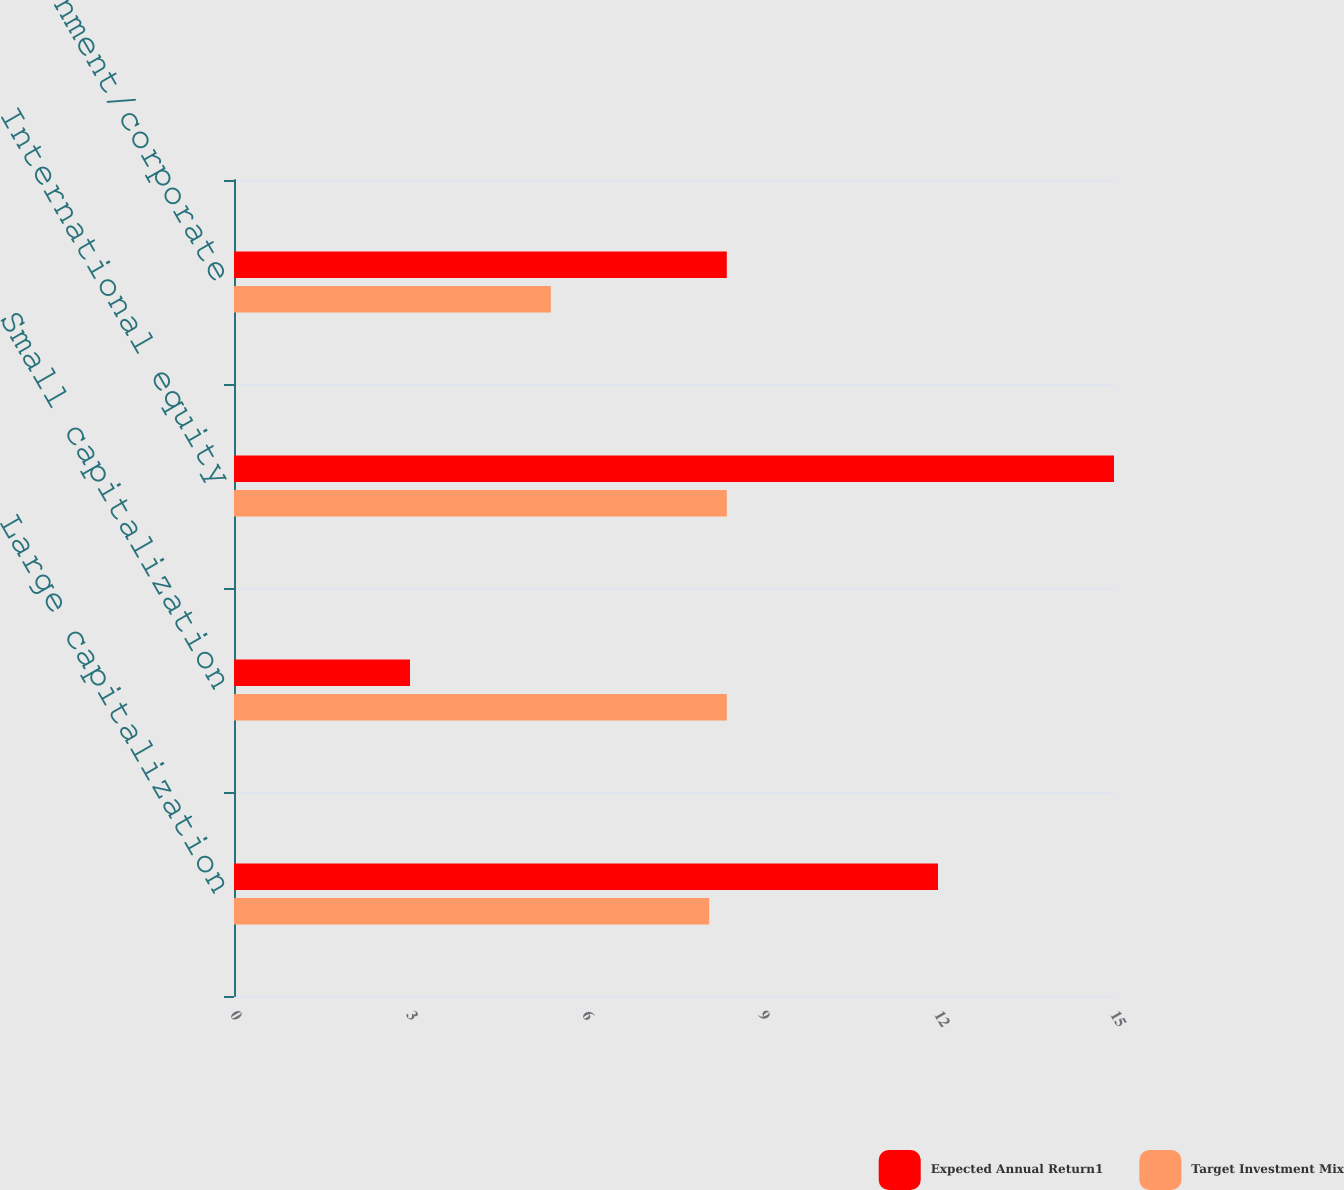Convert chart. <chart><loc_0><loc_0><loc_500><loc_500><stacked_bar_chart><ecel><fcel>Large capitalization<fcel>Small capitalization<fcel>International equity<fcel>Long-term government/corporate<nl><fcel>Expected Annual Return1<fcel>12<fcel>3<fcel>15<fcel>8.4<nl><fcel>Target Investment Mix<fcel>8.1<fcel>8.4<fcel>8.4<fcel>5.4<nl></chart> 